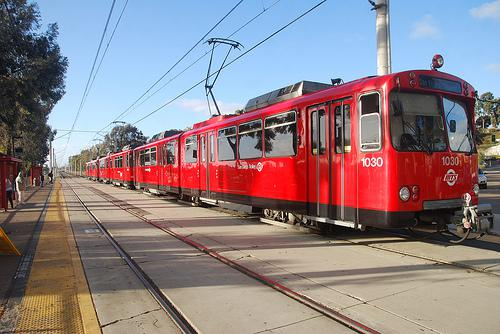Question: where was the photo taken?
Choices:
A. Sidewalk.
B. Park.
C. Street.
D. Train station.
Answer with the letter. Answer: C Question: who took the photo?
Choices:
A. Bus driver.
B. Tourist.
C. Train conductor.
D. Mom.
Answer with the letter. Answer: B Question: when was the photo taken?
Choices:
A. Morning.
B. Evening.
C. Afternoon.
D. Daytime.
Answer with the letter. Answer: C Question: what color is the train?
Choices:
A. Red.
B. Green.
C. Blue.
D. White.
Answer with the letter. Answer: A 